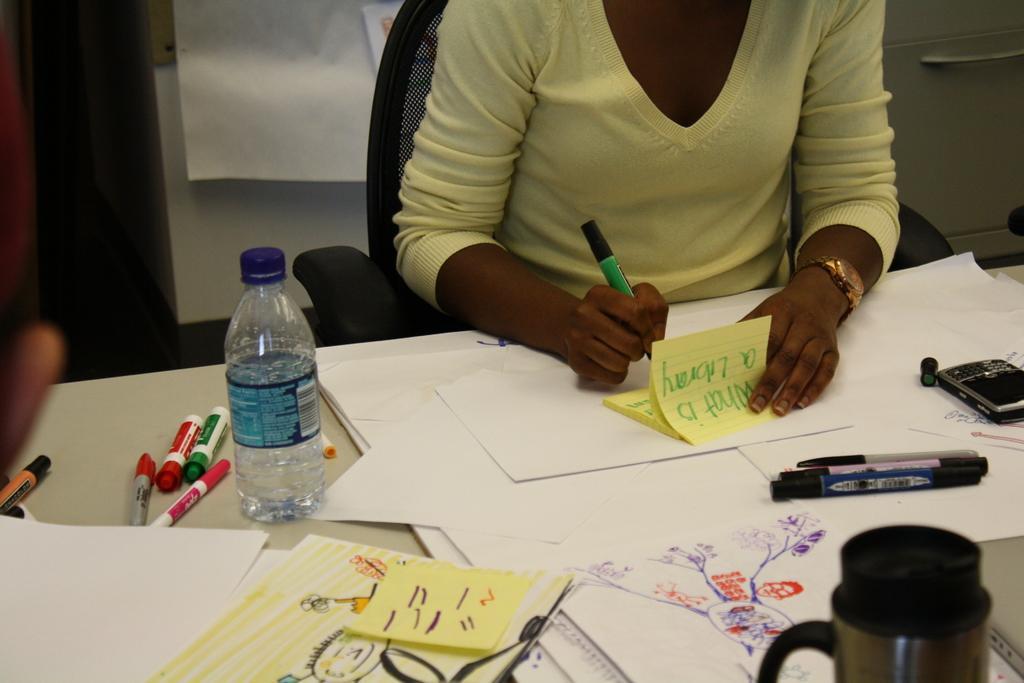Can you describe this image briefly? In this image I can see a person sitting on the chair and holding a pen. In front of her there is a table. On the table there is a bottle,paper,pens and the flask. 